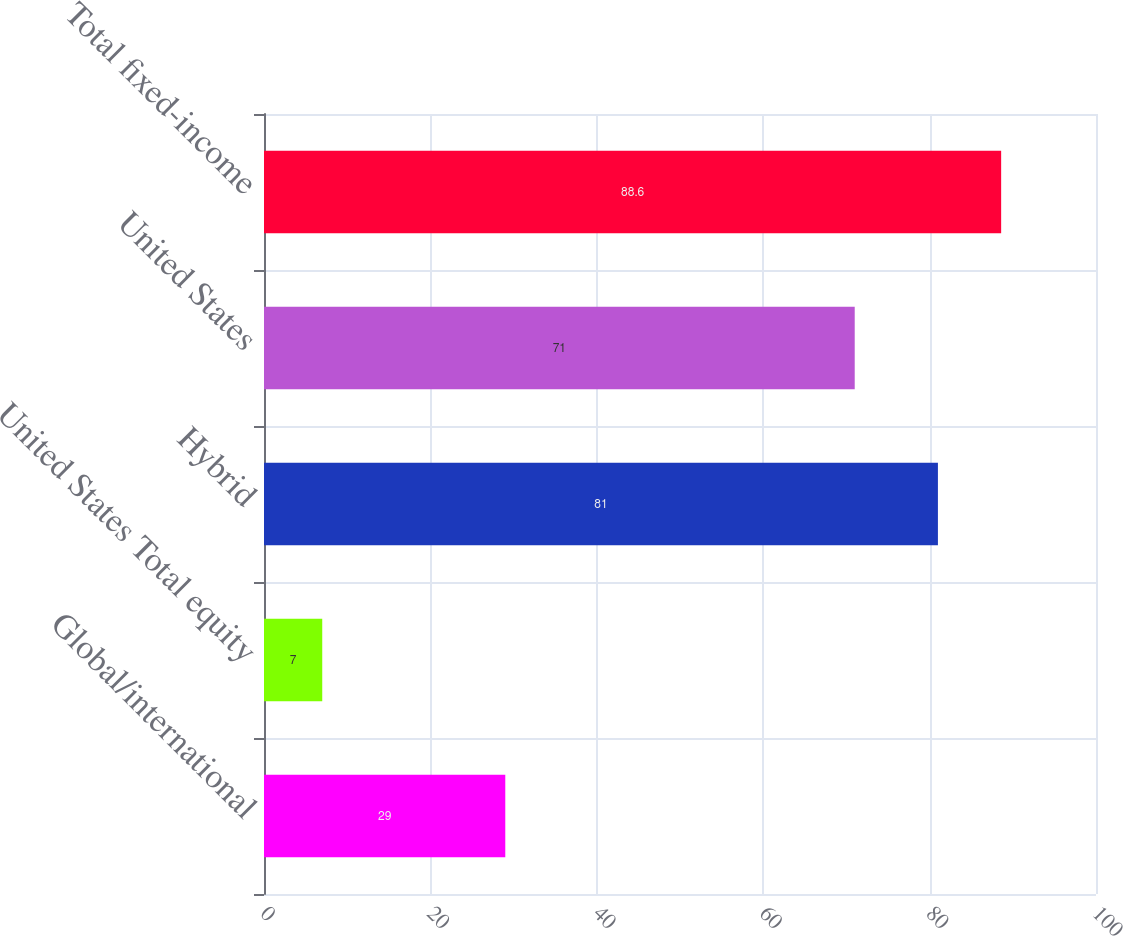Convert chart. <chart><loc_0><loc_0><loc_500><loc_500><bar_chart><fcel>Global/international<fcel>United States Total equity<fcel>Hybrid<fcel>United States<fcel>Total fixed-income<nl><fcel>29<fcel>7<fcel>81<fcel>71<fcel>88.6<nl></chart> 